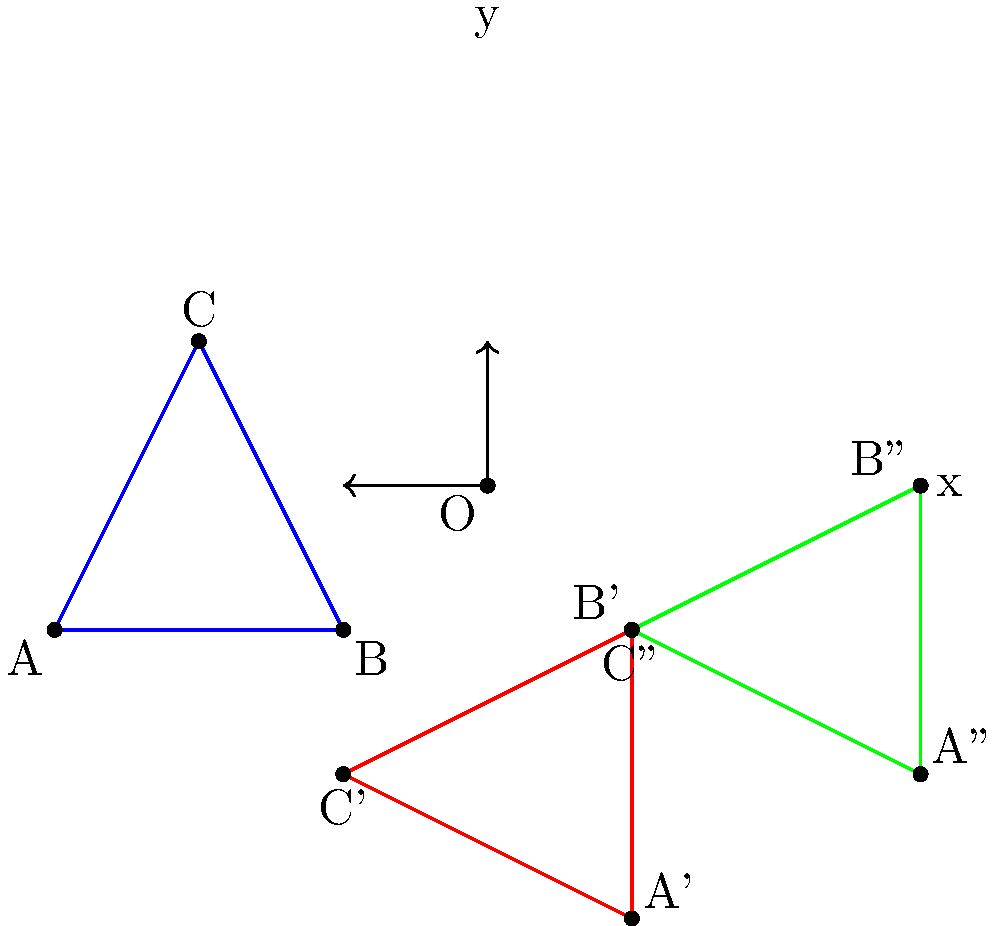Consider the blue triangle ABC in the coordinate plane. It undergoes two transformations: first, a 90-degree clockwise rotation around point O (3,1), followed by a translation of 2 units right and 1 unit up. What are the coordinates of point A after these transformations? Let's approach this step-by-step:

1) First, we need to perform a 90-degree clockwise rotation around point O (3,1).
   - To rotate a point (x,y) by 90 degrees clockwise around (a,b), we use:
     $$(x',y') = (a + (y-b), b - (x-a))$$

2) The original coordinates of point A are (0,0).
   Applying the rotation formula:
   $$x' = 3 + (0-1) = 2$$
   $$y' = 1 - (0-3) = 4$$
   So, after rotation, A' is at (2,4).

3) Next, we apply the translation of 2 units right and 1 unit up.
   - To translate, we simply add the translation vector to our point.
   - The translation vector is (2,1).

4) Adding this to our rotated point:
   $$(2,4) + (2,1) = (4,5)$$

Therefore, after both transformations, point A ends up at (4,5).
Answer: (4,5) 